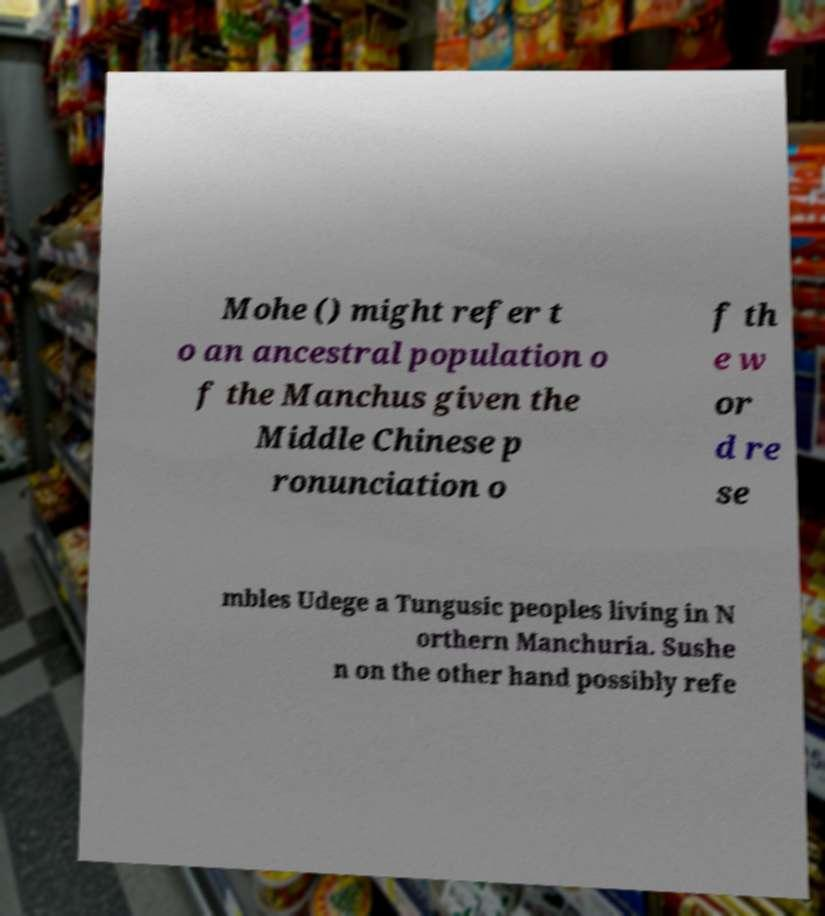For documentation purposes, I need the text within this image transcribed. Could you provide that? Mohe () might refer t o an ancestral population o f the Manchus given the Middle Chinese p ronunciation o f th e w or d re se mbles Udege a Tungusic peoples living in N orthern Manchuria. Sushe n on the other hand possibly refe 